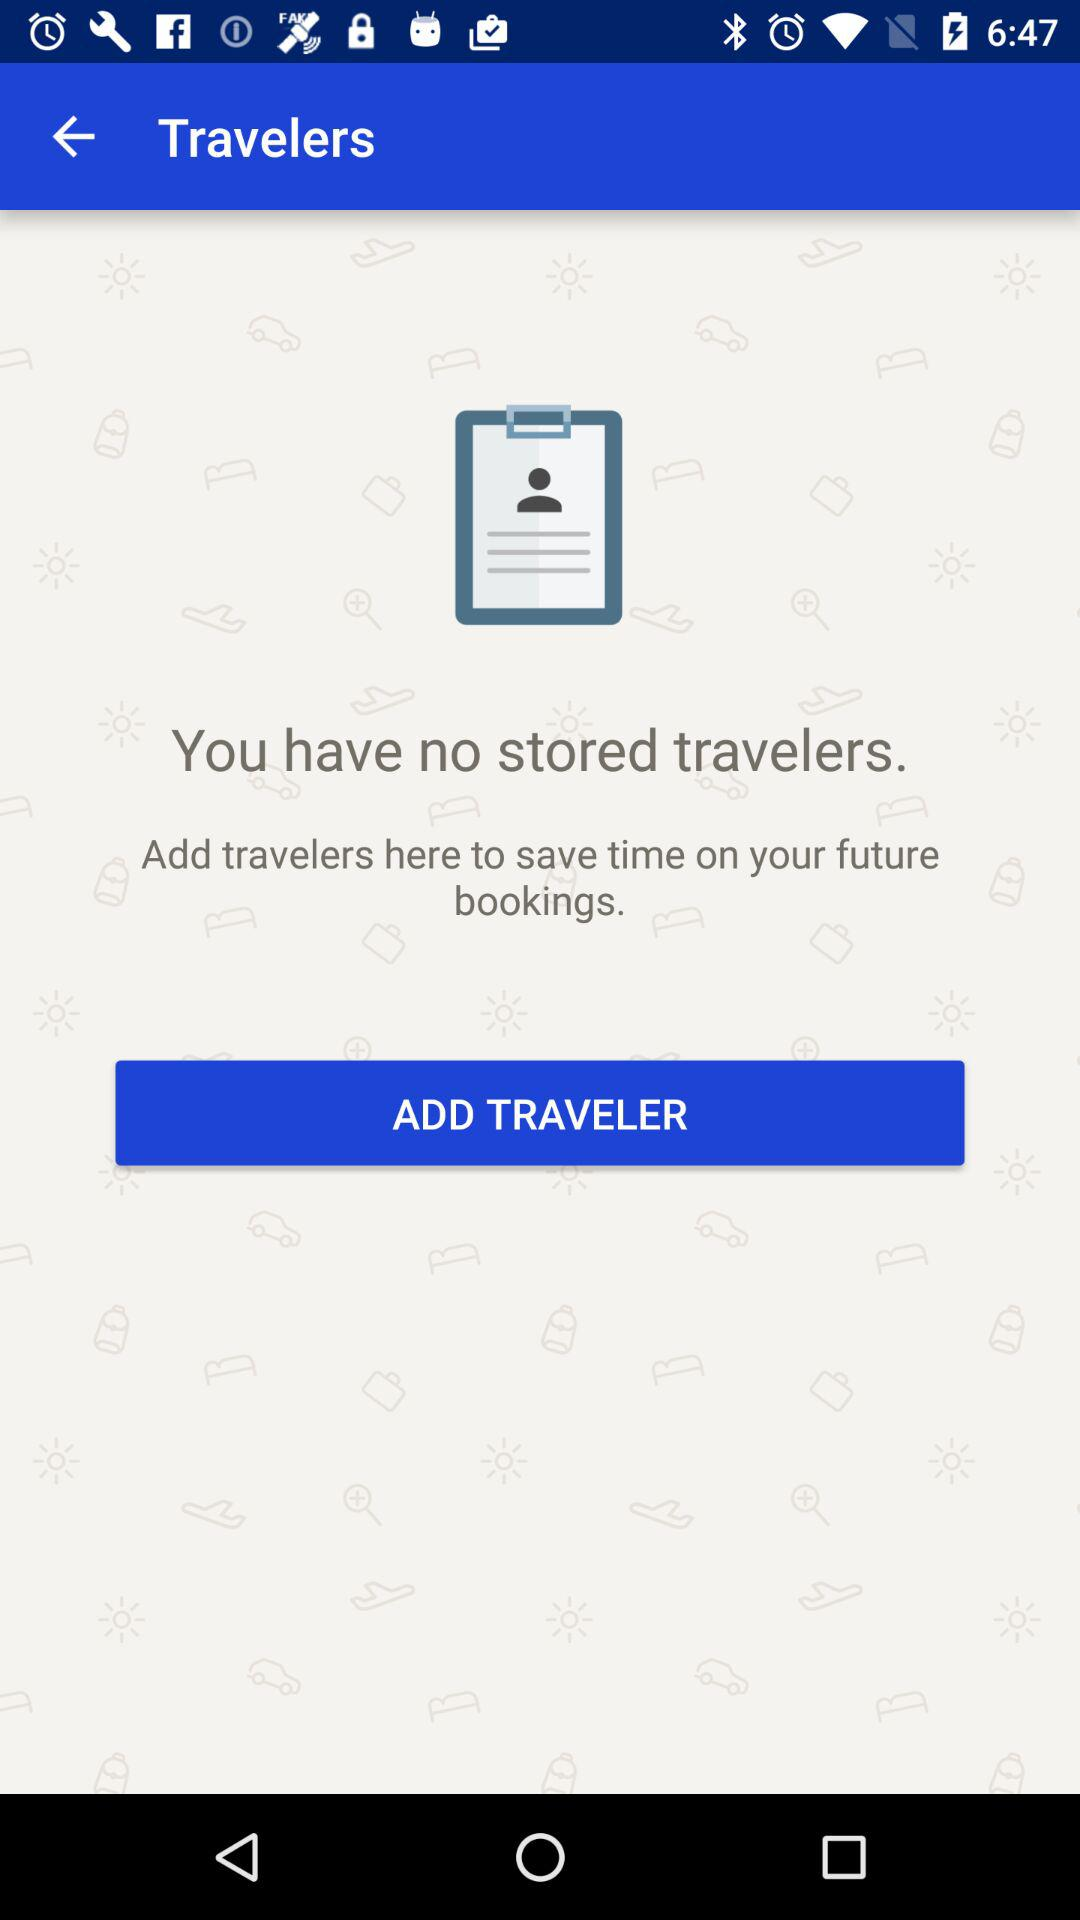How many travelers are currently stored in the app?
Answer the question using a single word or phrase. 0 